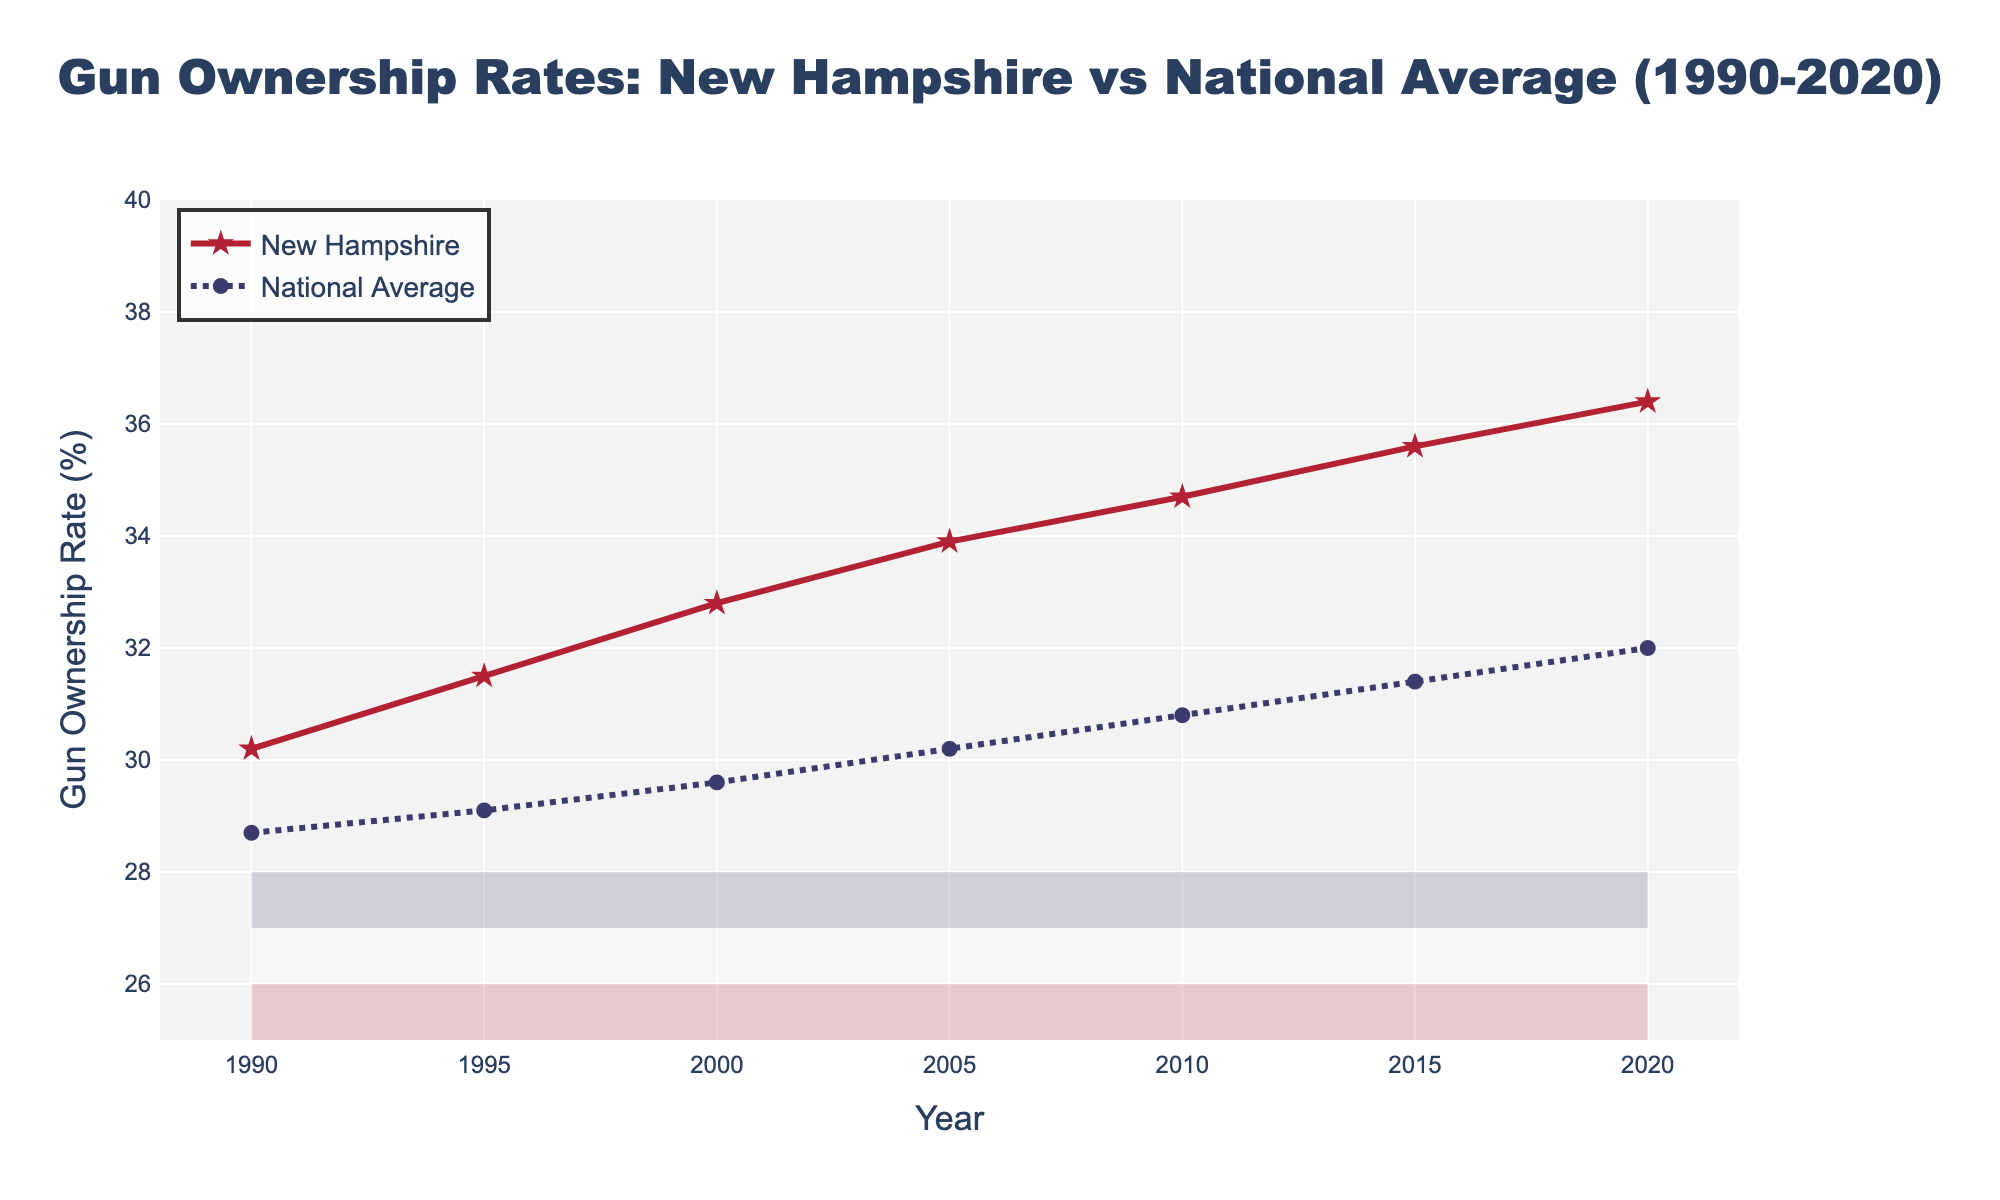What's the trend in New Hampshire gun ownership rates from 1990 to 2020? Observing the line representing New Hampshire, it rises consistently from 1990 to 2020, indicating an upward trend over this period.
Answer: Upward Which year had the highest gun ownership rate in New Hampshire? The peak of the red line (New Hampshire) occurs in 2020. Looking at the corresponding value, it’s around 36.4%.
Answer: 2020 How many percentage points did New Hampshire's gun ownership rate increase from 1990 to 2020? The New Hampshire rate in 1990 was 30.2% and in 2020 it was 36.4%. The difference is 36.4% - 30.2% = 6.2 percentage points.
Answer: 6.2 percentage points How does the gun ownership rate in New Hampshire in 2010 compare to the national average that year? In 2010, the New Hampshire rate was 34.7%, while the national average was 30.8%. New Hampshire's rate was higher.
Answer: Higher What is the average national gun ownership rate from 1990 to 2020? Adding the national rates and dividing by the number of years: (28.7 + 29.1 + 29.6 + 30.2 + 30.8 + 31.4 + 32.0) / 7 ≈ 30.26
Answer: 30.26% Was there any year when the national average gun ownership rate was higher than New Hampshire’s? By observing both lines across the entire time span (1990-2020), the blue line (national) is never above the red line (New Hampshire).
Answer: No What color is used to represent the national average gun ownership rate? The national average line is represented with a blue colored, dotted line with circle markers.
Answer: Blue In which time period did both New Hampshire and the national average show the most significant increase? From 1990 to 2000, both lines show a significant rise. New Hampshire moved from 30.2% to 32.8%, and the national average moved from 28.7% to 29.6%.
Answer: 1990-2000 Compare the increase in gun ownership rates between New Hampshire and the national average from 1995 to 2000. In 1995, New Hampshire was 31.5% and in 2000 it was 32.8%, a 1.3 percentage point increase. Nationally, it went from 29.1% to 29.6%, a 0.5 percentage point increase.
Answer: New Hampshire: 1.3%, National: 0.5% 